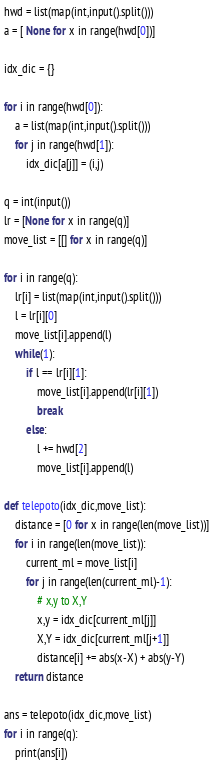<code> <loc_0><loc_0><loc_500><loc_500><_Python_>hwd = list(map(int,input().split()))
a = [ None for x in range(hwd[0])]

idx_dic = {}

for i in range(hwd[0]):
    a = list(map(int,input().split()))
    for j in range(hwd[1]):
        idx_dic[a[j]] = (i,j)
    
q = int(input())
lr = [None for x in range(q)]
move_list = [[] for x in range(q)]

for i in range(q):
    lr[i] = list(map(int,input().split()))
    l = lr[i][0]
    move_list[i].append(l)
    while(1):
        if l == lr[i][1]:
            move_list[i].append(lr[i][1])
            break
        else:
            l += hwd[2]
            move_list[i].append(l)

def telepoto(idx_dic,move_list):
    distance = [0 for x in range(len(move_list))]
    for i in range(len(move_list)):
        current_ml = move_list[i]
        for j in range(len(current_ml)-1):
            # x,y to X,Y
            x,y = idx_dic[current_ml[j]]
            X,Y = idx_dic[current_ml[j+1]]
            distance[i] += abs(x-X) + abs(y-Y)
    return distance

ans = telepoto(idx_dic,move_list)
for i in range(q):
    print(ans[i])
</code> 